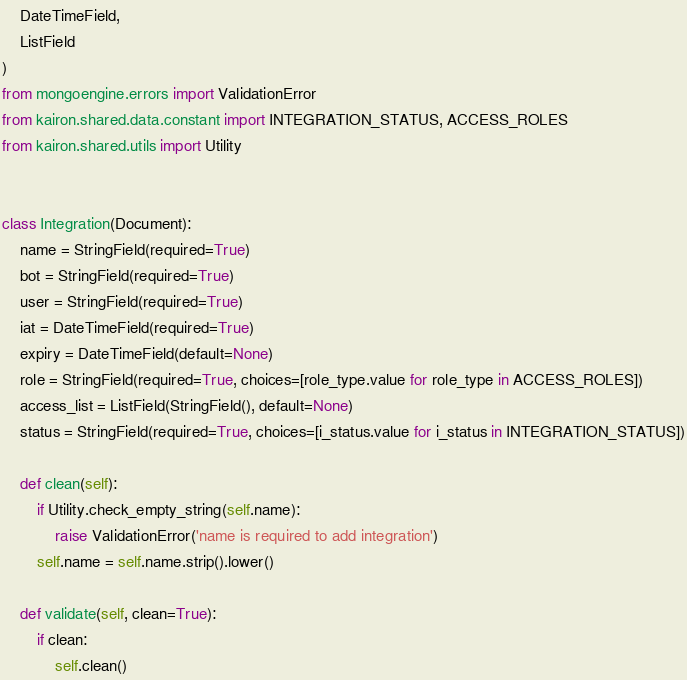<code> <loc_0><loc_0><loc_500><loc_500><_Python_>    DateTimeField,
    ListField
)
from mongoengine.errors import ValidationError
from kairon.shared.data.constant import INTEGRATION_STATUS, ACCESS_ROLES
from kairon.shared.utils import Utility


class Integration(Document):
    name = StringField(required=True)
    bot = StringField(required=True)
    user = StringField(required=True)
    iat = DateTimeField(required=True)
    expiry = DateTimeField(default=None)
    role = StringField(required=True, choices=[role_type.value for role_type in ACCESS_ROLES])
    access_list = ListField(StringField(), default=None)
    status = StringField(required=True, choices=[i_status.value for i_status in INTEGRATION_STATUS])

    def clean(self):
        if Utility.check_empty_string(self.name):
            raise ValidationError('name is required to add integration')
        self.name = self.name.strip().lower()

    def validate(self, clean=True):
        if clean:
            self.clean()
</code> 